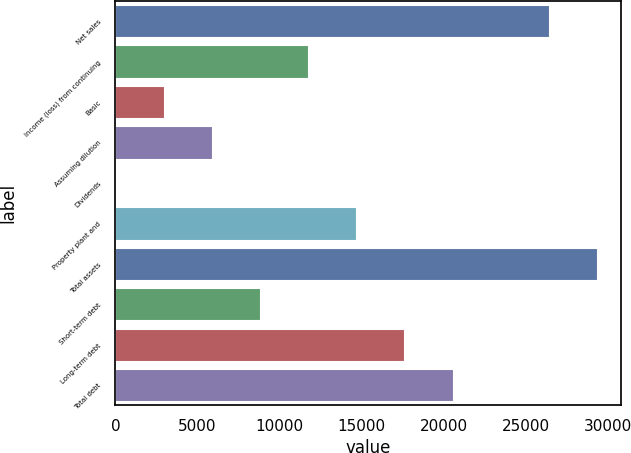<chart> <loc_0><loc_0><loc_500><loc_500><bar_chart><fcel>Net sales<fcel>Income (loss) from continuing<fcel>Basic<fcel>Assuming dilution<fcel>Dividends<fcel>Property plant and<fcel>Total assets<fcel>Short-term debt<fcel>Long-term debt<fcel>Total debt<nl><fcel>26382.7<fcel>11726.1<fcel>2932.08<fcel>5863.41<fcel>0.75<fcel>14657.4<fcel>29314<fcel>8794.74<fcel>17588.7<fcel>20520<nl></chart> 